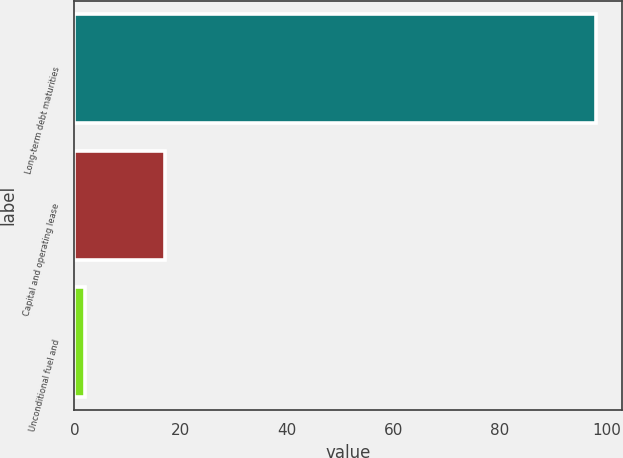Convert chart to OTSL. <chart><loc_0><loc_0><loc_500><loc_500><bar_chart><fcel>Long-term debt maturities<fcel>Capital and operating lease<fcel>Unconditional fuel and<nl><fcel>98<fcel>17<fcel>2<nl></chart> 